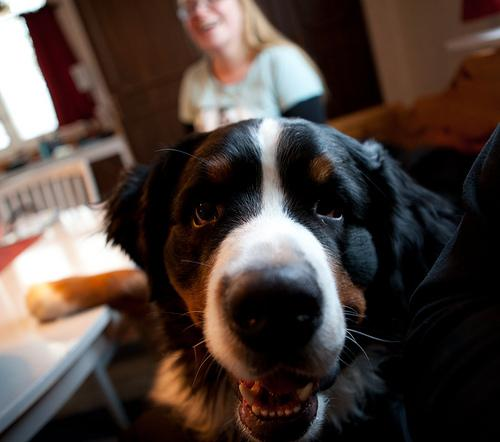In a short sentence, explain if the woman in the image appears happy or not. The woman in the image appears happy and is smiling. Identify the main animal in the image and what color it is. The main animal in the image is a black and white dog. Mention one facial feature of the dog and its color. One facial feature of the dog is its rounded black nose. Briefly mention the color and the piece of furniture in the image, aside from the table. A white chair can be seen by the table. Where is the dog's paw and what is it resting on? The dog's paw is resting on a shiny white table. What distinctive marking does the dog have on its head? The dog has a white stripe on its forehead. Is the dog showing any teeth in the image? If so, describe their appearance. Yes, the dog is showing several pointy canine teeth and little front teeth in its mouth. Describe the person in the background of the image, including their hair and clothing colors. The person in the background is a woman with long straight blonde hair, wearing a black and white shirt and glasses. Describe the setting of the image. The setting is a living room with a white table, chair, and wall, with a window in the background. 